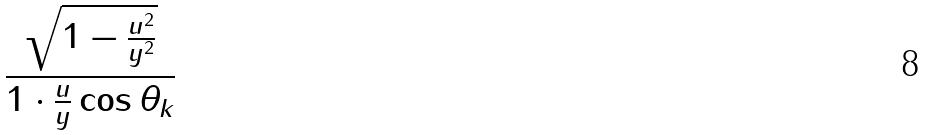<formula> <loc_0><loc_0><loc_500><loc_500>\frac { \sqrt { 1 - \frac { u ^ { 2 } } { y ^ { 2 } } } } { 1 \cdot \frac { u } { y } \cos \theta _ { k } }</formula> 